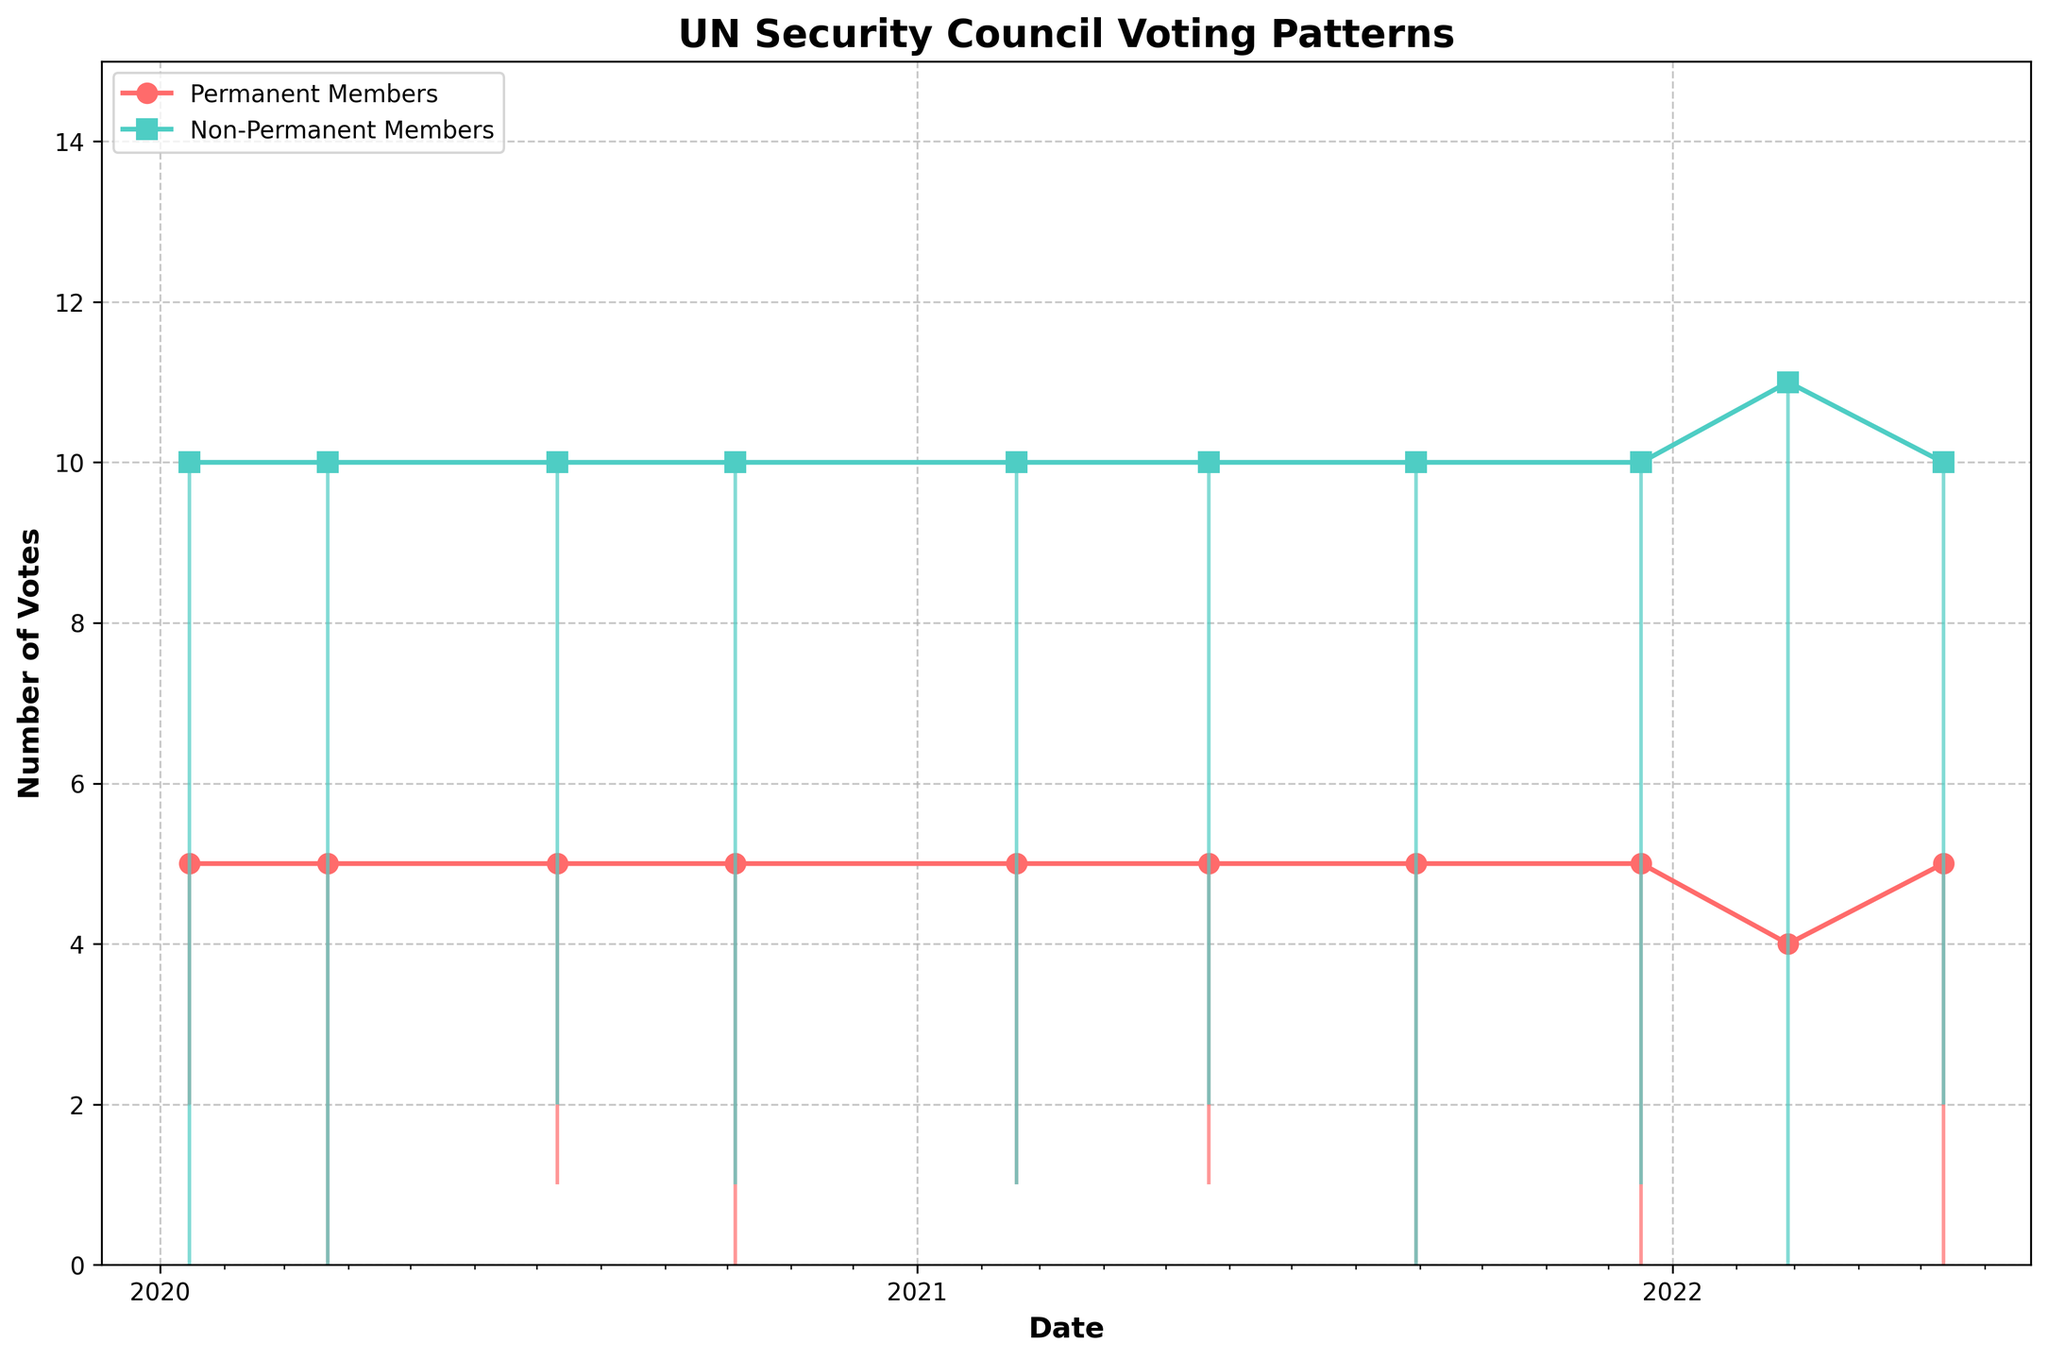what is the title of the figure? The title of the figure is displayed at the top of the plot. In this case, it is "UN Security Council Voting Patterns."
Answer: UN Security Council Voting Patterns how many dates are there in the figure? By counting the distinct data points or X-axis labels, we see there are 10 distinct dates represented in the figure.
Answer: 10 which date(s) had equal votes among permanent and non-permanent members? To find the dates with equal votes, compare both lines on the Y-axis. The dates for 2020-01-15, 2020-03-22, 2021-08-30, and 2022-02-26 show overlapping positions, indicating equal votes.
Answer: 2020-01-15, 2020-03-22, 2021-08-30, 2022-02-26 which issue had the highest number of votes from non-permanent members? Look for the highest point reached by the non-permanent member line (colored in turquoise). It occurs on the date corresponding to the "Ukraine Invasion" issue.
Answer: Ukraine Invasion how many times did non-permanent members have abstain votes? Examine the turquoise vertical bars extending downwards from the non-permanent member line. There are two occurrences where these bars are visible, meaning there were two instances of abstain votes by non-permanent members.
Answer: 2 what is the date with the minimum number of votes from permanent members? Identify the lowest point on the red line (permanent members' votes). The date corresponding to this lowest point is 2022-02-26 (Ukraine Invasion), where permanent members had only 1 vote.
Answer: 2022-02-26 which issue saw all permanent members and non-permanent members voting in favor? Each line segment should start from zero and not have any descent or plateau. Observing the plot, the issue "Yemen Ceasefire" (2020-03-22) fits this condition with both lines having peaks at the same level without dips.
Answer: Yemen Ceasefire compare the votes of permanent members on 'Climate Security' issue with the 'Israel-Palestine Conflict' issue Compare the red line segments for both issues. For "Climate Security" (2021-02-18), permanent members' votes are at 4 "for," 1 "against," while for "Israel-Palestine Conflict" (2021-05-22), it is the same. Hence, there is no difference.
Answer: Equal 